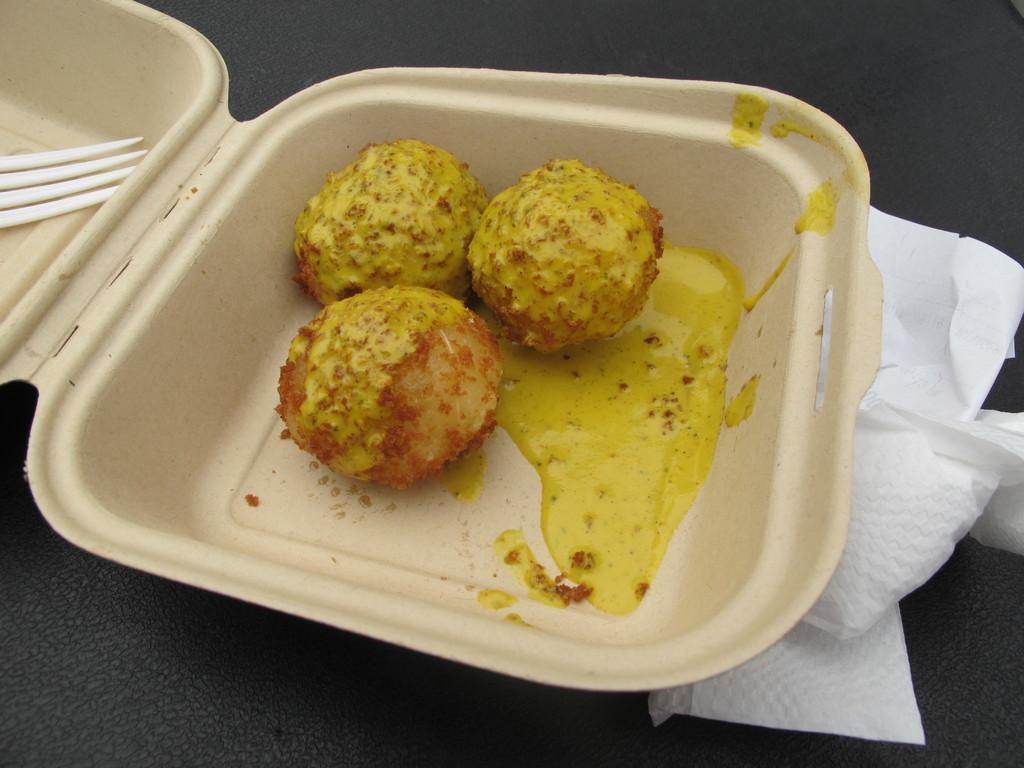In one or two sentences, can you explain what this image depicts? In this image we can see a box. Inside the box there is a food item and a fork. Below the box there are tissue papers. And the box is on a black surface. 